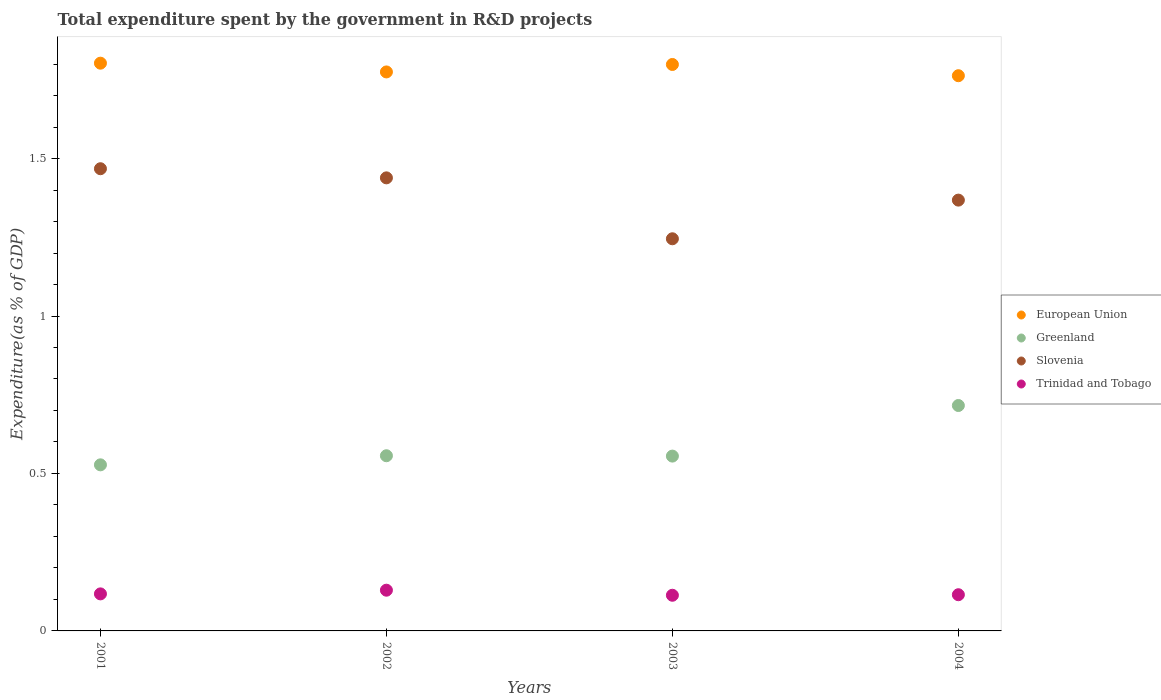How many different coloured dotlines are there?
Make the answer very short. 4. Is the number of dotlines equal to the number of legend labels?
Make the answer very short. Yes. What is the total expenditure spent by the government in R&D projects in European Union in 2001?
Your answer should be very brief. 1.8. Across all years, what is the maximum total expenditure spent by the government in R&D projects in Greenland?
Your response must be concise. 0.72. Across all years, what is the minimum total expenditure spent by the government in R&D projects in Greenland?
Offer a very short reply. 0.53. In which year was the total expenditure spent by the government in R&D projects in Greenland maximum?
Keep it short and to the point. 2004. In which year was the total expenditure spent by the government in R&D projects in European Union minimum?
Make the answer very short. 2004. What is the total total expenditure spent by the government in R&D projects in Greenland in the graph?
Offer a terse response. 2.35. What is the difference between the total expenditure spent by the government in R&D projects in European Union in 2001 and that in 2002?
Your answer should be very brief. 0.03. What is the difference between the total expenditure spent by the government in R&D projects in Trinidad and Tobago in 2002 and the total expenditure spent by the government in R&D projects in European Union in 2003?
Provide a succinct answer. -1.67. What is the average total expenditure spent by the government in R&D projects in Greenland per year?
Give a very brief answer. 0.59. In the year 2004, what is the difference between the total expenditure spent by the government in R&D projects in Trinidad and Tobago and total expenditure spent by the government in R&D projects in European Union?
Ensure brevity in your answer.  -1.65. In how many years, is the total expenditure spent by the government in R&D projects in European Union greater than 1.5 %?
Offer a terse response. 4. What is the ratio of the total expenditure spent by the government in R&D projects in Trinidad and Tobago in 2001 to that in 2002?
Offer a terse response. 0.91. Is the total expenditure spent by the government in R&D projects in European Union in 2001 less than that in 2002?
Offer a terse response. No. What is the difference between the highest and the second highest total expenditure spent by the government in R&D projects in Greenland?
Keep it short and to the point. 0.16. What is the difference between the highest and the lowest total expenditure spent by the government in R&D projects in European Union?
Your answer should be compact. 0.04. In how many years, is the total expenditure spent by the government in R&D projects in European Union greater than the average total expenditure spent by the government in R&D projects in European Union taken over all years?
Offer a terse response. 2. Is the sum of the total expenditure spent by the government in R&D projects in Slovenia in 2002 and 2003 greater than the maximum total expenditure spent by the government in R&D projects in Greenland across all years?
Provide a short and direct response. Yes. Is the total expenditure spent by the government in R&D projects in Slovenia strictly greater than the total expenditure spent by the government in R&D projects in Greenland over the years?
Make the answer very short. Yes. What is the difference between two consecutive major ticks on the Y-axis?
Offer a very short reply. 0.5. Are the values on the major ticks of Y-axis written in scientific E-notation?
Offer a very short reply. No. Does the graph contain any zero values?
Your answer should be very brief. No. How are the legend labels stacked?
Your answer should be very brief. Vertical. What is the title of the graph?
Offer a very short reply. Total expenditure spent by the government in R&D projects. Does "Nigeria" appear as one of the legend labels in the graph?
Give a very brief answer. No. What is the label or title of the X-axis?
Your answer should be very brief. Years. What is the label or title of the Y-axis?
Provide a short and direct response. Expenditure(as % of GDP). What is the Expenditure(as % of GDP) in European Union in 2001?
Ensure brevity in your answer.  1.8. What is the Expenditure(as % of GDP) of Greenland in 2001?
Ensure brevity in your answer.  0.53. What is the Expenditure(as % of GDP) in Slovenia in 2001?
Your response must be concise. 1.47. What is the Expenditure(as % of GDP) of Trinidad and Tobago in 2001?
Provide a short and direct response. 0.12. What is the Expenditure(as % of GDP) of European Union in 2002?
Make the answer very short. 1.78. What is the Expenditure(as % of GDP) of Greenland in 2002?
Your response must be concise. 0.56. What is the Expenditure(as % of GDP) of Slovenia in 2002?
Make the answer very short. 1.44. What is the Expenditure(as % of GDP) in Trinidad and Tobago in 2002?
Ensure brevity in your answer.  0.13. What is the Expenditure(as % of GDP) in European Union in 2003?
Make the answer very short. 1.8. What is the Expenditure(as % of GDP) of Greenland in 2003?
Your answer should be compact. 0.56. What is the Expenditure(as % of GDP) in Slovenia in 2003?
Keep it short and to the point. 1.25. What is the Expenditure(as % of GDP) in Trinidad and Tobago in 2003?
Your answer should be very brief. 0.11. What is the Expenditure(as % of GDP) of European Union in 2004?
Your response must be concise. 1.76. What is the Expenditure(as % of GDP) in Greenland in 2004?
Offer a terse response. 0.72. What is the Expenditure(as % of GDP) of Slovenia in 2004?
Keep it short and to the point. 1.37. What is the Expenditure(as % of GDP) in Trinidad and Tobago in 2004?
Keep it short and to the point. 0.11. Across all years, what is the maximum Expenditure(as % of GDP) of European Union?
Offer a terse response. 1.8. Across all years, what is the maximum Expenditure(as % of GDP) in Greenland?
Provide a short and direct response. 0.72. Across all years, what is the maximum Expenditure(as % of GDP) in Slovenia?
Give a very brief answer. 1.47. Across all years, what is the maximum Expenditure(as % of GDP) in Trinidad and Tobago?
Your response must be concise. 0.13. Across all years, what is the minimum Expenditure(as % of GDP) of European Union?
Provide a succinct answer. 1.76. Across all years, what is the minimum Expenditure(as % of GDP) of Greenland?
Provide a succinct answer. 0.53. Across all years, what is the minimum Expenditure(as % of GDP) of Slovenia?
Provide a short and direct response. 1.25. Across all years, what is the minimum Expenditure(as % of GDP) in Trinidad and Tobago?
Make the answer very short. 0.11. What is the total Expenditure(as % of GDP) in European Union in the graph?
Give a very brief answer. 7.14. What is the total Expenditure(as % of GDP) of Greenland in the graph?
Your answer should be very brief. 2.35. What is the total Expenditure(as % of GDP) of Slovenia in the graph?
Your answer should be compact. 5.52. What is the total Expenditure(as % of GDP) in Trinidad and Tobago in the graph?
Ensure brevity in your answer.  0.48. What is the difference between the Expenditure(as % of GDP) in European Union in 2001 and that in 2002?
Ensure brevity in your answer.  0.03. What is the difference between the Expenditure(as % of GDP) of Greenland in 2001 and that in 2002?
Keep it short and to the point. -0.03. What is the difference between the Expenditure(as % of GDP) in Slovenia in 2001 and that in 2002?
Give a very brief answer. 0.03. What is the difference between the Expenditure(as % of GDP) of Trinidad and Tobago in 2001 and that in 2002?
Give a very brief answer. -0.01. What is the difference between the Expenditure(as % of GDP) in European Union in 2001 and that in 2003?
Your answer should be very brief. 0. What is the difference between the Expenditure(as % of GDP) of Greenland in 2001 and that in 2003?
Your answer should be compact. -0.03. What is the difference between the Expenditure(as % of GDP) in Slovenia in 2001 and that in 2003?
Provide a succinct answer. 0.22. What is the difference between the Expenditure(as % of GDP) in Trinidad and Tobago in 2001 and that in 2003?
Give a very brief answer. 0. What is the difference between the Expenditure(as % of GDP) of European Union in 2001 and that in 2004?
Your answer should be compact. 0.04. What is the difference between the Expenditure(as % of GDP) in Greenland in 2001 and that in 2004?
Offer a very short reply. -0.19. What is the difference between the Expenditure(as % of GDP) of Slovenia in 2001 and that in 2004?
Make the answer very short. 0.1. What is the difference between the Expenditure(as % of GDP) in Trinidad and Tobago in 2001 and that in 2004?
Offer a very short reply. 0. What is the difference between the Expenditure(as % of GDP) in European Union in 2002 and that in 2003?
Your answer should be very brief. -0.02. What is the difference between the Expenditure(as % of GDP) of Greenland in 2002 and that in 2003?
Ensure brevity in your answer.  0. What is the difference between the Expenditure(as % of GDP) in Slovenia in 2002 and that in 2003?
Your answer should be very brief. 0.19. What is the difference between the Expenditure(as % of GDP) of Trinidad and Tobago in 2002 and that in 2003?
Ensure brevity in your answer.  0.02. What is the difference between the Expenditure(as % of GDP) of European Union in 2002 and that in 2004?
Make the answer very short. 0.01. What is the difference between the Expenditure(as % of GDP) of Greenland in 2002 and that in 2004?
Give a very brief answer. -0.16. What is the difference between the Expenditure(as % of GDP) of Slovenia in 2002 and that in 2004?
Keep it short and to the point. 0.07. What is the difference between the Expenditure(as % of GDP) of Trinidad and Tobago in 2002 and that in 2004?
Provide a succinct answer. 0.01. What is the difference between the Expenditure(as % of GDP) of European Union in 2003 and that in 2004?
Offer a very short reply. 0.04. What is the difference between the Expenditure(as % of GDP) in Greenland in 2003 and that in 2004?
Give a very brief answer. -0.16. What is the difference between the Expenditure(as % of GDP) in Slovenia in 2003 and that in 2004?
Offer a very short reply. -0.12. What is the difference between the Expenditure(as % of GDP) in Trinidad and Tobago in 2003 and that in 2004?
Ensure brevity in your answer.  -0. What is the difference between the Expenditure(as % of GDP) in European Union in 2001 and the Expenditure(as % of GDP) in Greenland in 2002?
Make the answer very short. 1.25. What is the difference between the Expenditure(as % of GDP) of European Union in 2001 and the Expenditure(as % of GDP) of Slovenia in 2002?
Provide a short and direct response. 0.36. What is the difference between the Expenditure(as % of GDP) in European Union in 2001 and the Expenditure(as % of GDP) in Trinidad and Tobago in 2002?
Make the answer very short. 1.67. What is the difference between the Expenditure(as % of GDP) of Greenland in 2001 and the Expenditure(as % of GDP) of Slovenia in 2002?
Offer a very short reply. -0.91. What is the difference between the Expenditure(as % of GDP) in Greenland in 2001 and the Expenditure(as % of GDP) in Trinidad and Tobago in 2002?
Ensure brevity in your answer.  0.4. What is the difference between the Expenditure(as % of GDP) of Slovenia in 2001 and the Expenditure(as % of GDP) of Trinidad and Tobago in 2002?
Offer a terse response. 1.34. What is the difference between the Expenditure(as % of GDP) in European Union in 2001 and the Expenditure(as % of GDP) in Greenland in 2003?
Make the answer very short. 1.25. What is the difference between the Expenditure(as % of GDP) in European Union in 2001 and the Expenditure(as % of GDP) in Slovenia in 2003?
Provide a succinct answer. 0.56. What is the difference between the Expenditure(as % of GDP) of European Union in 2001 and the Expenditure(as % of GDP) of Trinidad and Tobago in 2003?
Provide a short and direct response. 1.69. What is the difference between the Expenditure(as % of GDP) of Greenland in 2001 and the Expenditure(as % of GDP) of Slovenia in 2003?
Give a very brief answer. -0.72. What is the difference between the Expenditure(as % of GDP) of Greenland in 2001 and the Expenditure(as % of GDP) of Trinidad and Tobago in 2003?
Provide a succinct answer. 0.41. What is the difference between the Expenditure(as % of GDP) of Slovenia in 2001 and the Expenditure(as % of GDP) of Trinidad and Tobago in 2003?
Offer a very short reply. 1.35. What is the difference between the Expenditure(as % of GDP) in European Union in 2001 and the Expenditure(as % of GDP) in Greenland in 2004?
Your answer should be compact. 1.09. What is the difference between the Expenditure(as % of GDP) of European Union in 2001 and the Expenditure(as % of GDP) of Slovenia in 2004?
Offer a very short reply. 0.43. What is the difference between the Expenditure(as % of GDP) of European Union in 2001 and the Expenditure(as % of GDP) of Trinidad and Tobago in 2004?
Ensure brevity in your answer.  1.69. What is the difference between the Expenditure(as % of GDP) of Greenland in 2001 and the Expenditure(as % of GDP) of Slovenia in 2004?
Provide a short and direct response. -0.84. What is the difference between the Expenditure(as % of GDP) of Greenland in 2001 and the Expenditure(as % of GDP) of Trinidad and Tobago in 2004?
Your response must be concise. 0.41. What is the difference between the Expenditure(as % of GDP) in Slovenia in 2001 and the Expenditure(as % of GDP) in Trinidad and Tobago in 2004?
Make the answer very short. 1.35. What is the difference between the Expenditure(as % of GDP) of European Union in 2002 and the Expenditure(as % of GDP) of Greenland in 2003?
Make the answer very short. 1.22. What is the difference between the Expenditure(as % of GDP) of European Union in 2002 and the Expenditure(as % of GDP) of Slovenia in 2003?
Your answer should be compact. 0.53. What is the difference between the Expenditure(as % of GDP) in European Union in 2002 and the Expenditure(as % of GDP) in Trinidad and Tobago in 2003?
Offer a very short reply. 1.66. What is the difference between the Expenditure(as % of GDP) in Greenland in 2002 and the Expenditure(as % of GDP) in Slovenia in 2003?
Your answer should be very brief. -0.69. What is the difference between the Expenditure(as % of GDP) of Greenland in 2002 and the Expenditure(as % of GDP) of Trinidad and Tobago in 2003?
Offer a very short reply. 0.44. What is the difference between the Expenditure(as % of GDP) in Slovenia in 2002 and the Expenditure(as % of GDP) in Trinidad and Tobago in 2003?
Give a very brief answer. 1.33. What is the difference between the Expenditure(as % of GDP) in European Union in 2002 and the Expenditure(as % of GDP) in Greenland in 2004?
Keep it short and to the point. 1.06. What is the difference between the Expenditure(as % of GDP) in European Union in 2002 and the Expenditure(as % of GDP) in Slovenia in 2004?
Give a very brief answer. 0.41. What is the difference between the Expenditure(as % of GDP) of European Union in 2002 and the Expenditure(as % of GDP) of Trinidad and Tobago in 2004?
Provide a short and direct response. 1.66. What is the difference between the Expenditure(as % of GDP) of Greenland in 2002 and the Expenditure(as % of GDP) of Slovenia in 2004?
Provide a succinct answer. -0.81. What is the difference between the Expenditure(as % of GDP) of Greenland in 2002 and the Expenditure(as % of GDP) of Trinidad and Tobago in 2004?
Make the answer very short. 0.44. What is the difference between the Expenditure(as % of GDP) in Slovenia in 2002 and the Expenditure(as % of GDP) in Trinidad and Tobago in 2004?
Keep it short and to the point. 1.32. What is the difference between the Expenditure(as % of GDP) of European Union in 2003 and the Expenditure(as % of GDP) of Greenland in 2004?
Your answer should be very brief. 1.08. What is the difference between the Expenditure(as % of GDP) in European Union in 2003 and the Expenditure(as % of GDP) in Slovenia in 2004?
Your answer should be very brief. 0.43. What is the difference between the Expenditure(as % of GDP) of European Union in 2003 and the Expenditure(as % of GDP) of Trinidad and Tobago in 2004?
Ensure brevity in your answer.  1.68. What is the difference between the Expenditure(as % of GDP) in Greenland in 2003 and the Expenditure(as % of GDP) in Slovenia in 2004?
Give a very brief answer. -0.81. What is the difference between the Expenditure(as % of GDP) in Greenland in 2003 and the Expenditure(as % of GDP) in Trinidad and Tobago in 2004?
Keep it short and to the point. 0.44. What is the difference between the Expenditure(as % of GDP) in Slovenia in 2003 and the Expenditure(as % of GDP) in Trinidad and Tobago in 2004?
Keep it short and to the point. 1.13. What is the average Expenditure(as % of GDP) of European Union per year?
Provide a short and direct response. 1.78. What is the average Expenditure(as % of GDP) of Greenland per year?
Ensure brevity in your answer.  0.59. What is the average Expenditure(as % of GDP) in Slovenia per year?
Your answer should be compact. 1.38. What is the average Expenditure(as % of GDP) of Trinidad and Tobago per year?
Give a very brief answer. 0.12. In the year 2001, what is the difference between the Expenditure(as % of GDP) in European Union and Expenditure(as % of GDP) in Greenland?
Offer a very short reply. 1.28. In the year 2001, what is the difference between the Expenditure(as % of GDP) in European Union and Expenditure(as % of GDP) in Slovenia?
Provide a succinct answer. 0.34. In the year 2001, what is the difference between the Expenditure(as % of GDP) in European Union and Expenditure(as % of GDP) in Trinidad and Tobago?
Your answer should be compact. 1.69. In the year 2001, what is the difference between the Expenditure(as % of GDP) of Greenland and Expenditure(as % of GDP) of Slovenia?
Give a very brief answer. -0.94. In the year 2001, what is the difference between the Expenditure(as % of GDP) of Greenland and Expenditure(as % of GDP) of Trinidad and Tobago?
Make the answer very short. 0.41. In the year 2001, what is the difference between the Expenditure(as % of GDP) in Slovenia and Expenditure(as % of GDP) in Trinidad and Tobago?
Your response must be concise. 1.35. In the year 2002, what is the difference between the Expenditure(as % of GDP) of European Union and Expenditure(as % of GDP) of Greenland?
Provide a short and direct response. 1.22. In the year 2002, what is the difference between the Expenditure(as % of GDP) of European Union and Expenditure(as % of GDP) of Slovenia?
Offer a very short reply. 0.34. In the year 2002, what is the difference between the Expenditure(as % of GDP) of European Union and Expenditure(as % of GDP) of Trinidad and Tobago?
Make the answer very short. 1.65. In the year 2002, what is the difference between the Expenditure(as % of GDP) of Greenland and Expenditure(as % of GDP) of Slovenia?
Offer a terse response. -0.88. In the year 2002, what is the difference between the Expenditure(as % of GDP) in Greenland and Expenditure(as % of GDP) in Trinidad and Tobago?
Provide a succinct answer. 0.43. In the year 2002, what is the difference between the Expenditure(as % of GDP) of Slovenia and Expenditure(as % of GDP) of Trinidad and Tobago?
Your answer should be compact. 1.31. In the year 2003, what is the difference between the Expenditure(as % of GDP) in European Union and Expenditure(as % of GDP) in Greenland?
Ensure brevity in your answer.  1.24. In the year 2003, what is the difference between the Expenditure(as % of GDP) of European Union and Expenditure(as % of GDP) of Slovenia?
Your answer should be very brief. 0.55. In the year 2003, what is the difference between the Expenditure(as % of GDP) of European Union and Expenditure(as % of GDP) of Trinidad and Tobago?
Make the answer very short. 1.69. In the year 2003, what is the difference between the Expenditure(as % of GDP) of Greenland and Expenditure(as % of GDP) of Slovenia?
Make the answer very short. -0.69. In the year 2003, what is the difference between the Expenditure(as % of GDP) in Greenland and Expenditure(as % of GDP) in Trinidad and Tobago?
Give a very brief answer. 0.44. In the year 2003, what is the difference between the Expenditure(as % of GDP) of Slovenia and Expenditure(as % of GDP) of Trinidad and Tobago?
Your answer should be very brief. 1.13. In the year 2004, what is the difference between the Expenditure(as % of GDP) of European Union and Expenditure(as % of GDP) of Greenland?
Your answer should be very brief. 1.05. In the year 2004, what is the difference between the Expenditure(as % of GDP) of European Union and Expenditure(as % of GDP) of Slovenia?
Ensure brevity in your answer.  0.4. In the year 2004, what is the difference between the Expenditure(as % of GDP) of European Union and Expenditure(as % of GDP) of Trinidad and Tobago?
Make the answer very short. 1.65. In the year 2004, what is the difference between the Expenditure(as % of GDP) in Greenland and Expenditure(as % of GDP) in Slovenia?
Make the answer very short. -0.65. In the year 2004, what is the difference between the Expenditure(as % of GDP) in Greenland and Expenditure(as % of GDP) in Trinidad and Tobago?
Give a very brief answer. 0.6. In the year 2004, what is the difference between the Expenditure(as % of GDP) in Slovenia and Expenditure(as % of GDP) in Trinidad and Tobago?
Offer a very short reply. 1.25. What is the ratio of the Expenditure(as % of GDP) in European Union in 2001 to that in 2002?
Your answer should be compact. 1.02. What is the ratio of the Expenditure(as % of GDP) of Greenland in 2001 to that in 2002?
Provide a succinct answer. 0.95. What is the ratio of the Expenditure(as % of GDP) of Slovenia in 2001 to that in 2002?
Provide a succinct answer. 1.02. What is the ratio of the Expenditure(as % of GDP) in Trinidad and Tobago in 2001 to that in 2002?
Keep it short and to the point. 0.91. What is the ratio of the Expenditure(as % of GDP) in European Union in 2001 to that in 2003?
Make the answer very short. 1. What is the ratio of the Expenditure(as % of GDP) of Slovenia in 2001 to that in 2003?
Your answer should be very brief. 1.18. What is the ratio of the Expenditure(as % of GDP) in Trinidad and Tobago in 2001 to that in 2003?
Provide a short and direct response. 1.04. What is the ratio of the Expenditure(as % of GDP) of European Union in 2001 to that in 2004?
Give a very brief answer. 1.02. What is the ratio of the Expenditure(as % of GDP) of Greenland in 2001 to that in 2004?
Your answer should be very brief. 0.74. What is the ratio of the Expenditure(as % of GDP) of Slovenia in 2001 to that in 2004?
Keep it short and to the point. 1.07. What is the ratio of the Expenditure(as % of GDP) of Trinidad and Tobago in 2001 to that in 2004?
Offer a very short reply. 1.02. What is the ratio of the Expenditure(as % of GDP) in European Union in 2002 to that in 2003?
Your answer should be very brief. 0.99. What is the ratio of the Expenditure(as % of GDP) of Greenland in 2002 to that in 2003?
Provide a short and direct response. 1. What is the ratio of the Expenditure(as % of GDP) in Slovenia in 2002 to that in 2003?
Give a very brief answer. 1.16. What is the ratio of the Expenditure(as % of GDP) in Trinidad and Tobago in 2002 to that in 2003?
Make the answer very short. 1.14. What is the ratio of the Expenditure(as % of GDP) of European Union in 2002 to that in 2004?
Keep it short and to the point. 1.01. What is the ratio of the Expenditure(as % of GDP) in Greenland in 2002 to that in 2004?
Give a very brief answer. 0.78. What is the ratio of the Expenditure(as % of GDP) of Slovenia in 2002 to that in 2004?
Your answer should be very brief. 1.05. What is the ratio of the Expenditure(as % of GDP) of European Union in 2003 to that in 2004?
Your response must be concise. 1.02. What is the ratio of the Expenditure(as % of GDP) of Greenland in 2003 to that in 2004?
Provide a succinct answer. 0.78. What is the ratio of the Expenditure(as % of GDP) in Slovenia in 2003 to that in 2004?
Your answer should be compact. 0.91. What is the ratio of the Expenditure(as % of GDP) in Trinidad and Tobago in 2003 to that in 2004?
Give a very brief answer. 0.99. What is the difference between the highest and the second highest Expenditure(as % of GDP) of European Union?
Ensure brevity in your answer.  0. What is the difference between the highest and the second highest Expenditure(as % of GDP) of Greenland?
Ensure brevity in your answer.  0.16. What is the difference between the highest and the second highest Expenditure(as % of GDP) in Slovenia?
Offer a very short reply. 0.03. What is the difference between the highest and the second highest Expenditure(as % of GDP) of Trinidad and Tobago?
Your answer should be very brief. 0.01. What is the difference between the highest and the lowest Expenditure(as % of GDP) in European Union?
Your response must be concise. 0.04. What is the difference between the highest and the lowest Expenditure(as % of GDP) in Greenland?
Provide a short and direct response. 0.19. What is the difference between the highest and the lowest Expenditure(as % of GDP) in Slovenia?
Make the answer very short. 0.22. What is the difference between the highest and the lowest Expenditure(as % of GDP) in Trinidad and Tobago?
Offer a terse response. 0.02. 